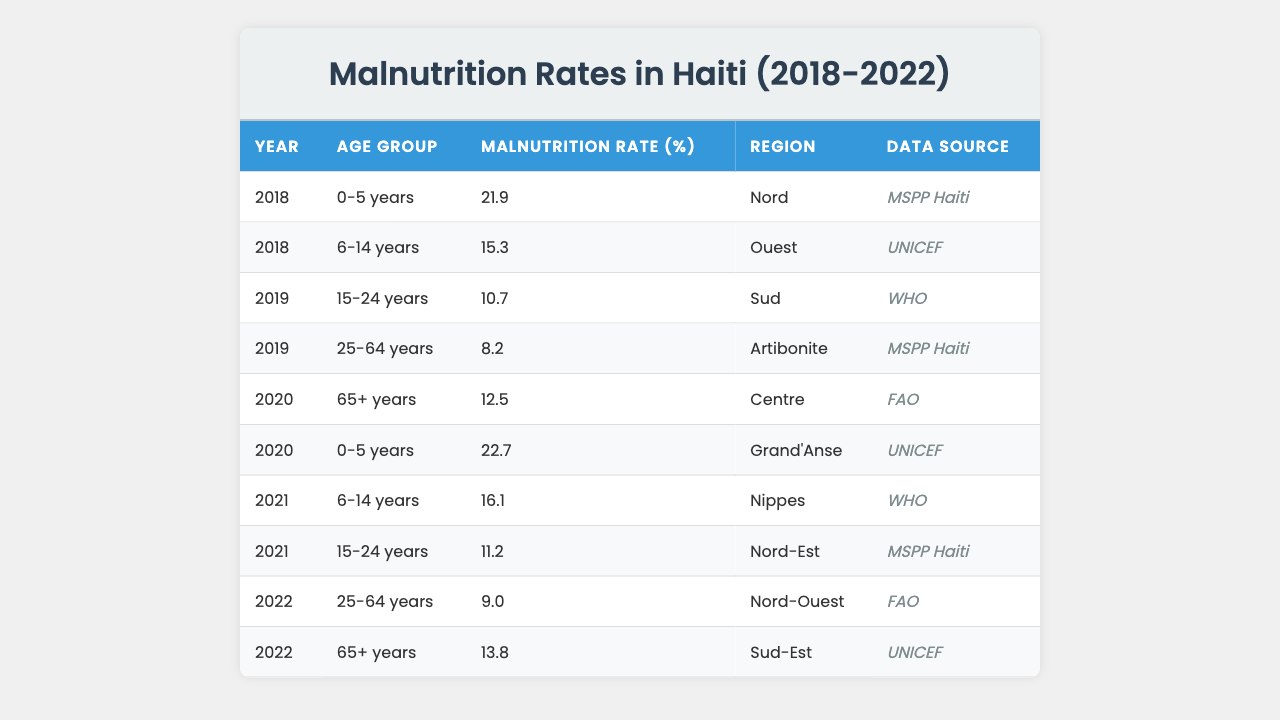What is the malnutrition rate for children aged 0-5 years in 2018? The table indicates that in 2018, the malnutrition rate for the age group 0-5 years is 21.9%.
Answer: 21.9% Which age group had the lowest malnutrition rate in 2019? In 2019, the malnutrition rates were 10.7% for 15-24 years and 8.2% for 25-64 years, making 25-64 years the lowest.
Answer: 25-64 years What was the malnutrition rate for the 65+ age group in 2020? According to the table, in 2020 the malnutrition rate for the 65+ age group is 12.5%.
Answer: 12.5% In how many years did the malnutrition rate for the 0-5 years age group increase from the previous year? The malnutrition rate for the 0-5 years age group increased from 21.9% in 2018 to 22.7% in 2020, indicating an increase for one year.
Answer: One year What is the average malnutrition rate across all age groups for the year 2022? The rates for 2022 are 9.0% for 25-64 years and 13.8% for 65+ years. Their average is (9.0 + 13.8) / 2 = 11.4%.
Answer: 11.4% Is the malnutrition rate for the 6-14 years age group higher in 2021 than in 2018? In 2018, the rate was 15.3% and in 2021 it was 16.1%, confirming that the rate in 2021 is indeed higher.
Answer: Yes How much did the malnutrition rate change for the 15-24 age group from 2019 to 2021? The rate in 2019 was 10.7% and in 2021 it was 11.2%. The change is 11.2% - 10.7% = 0.5%, indicating a small increase.
Answer: Increased by 0.5% Which region had the highest malnutrition rate for the 0-5 age group in 2020? The table shows that in 2020, the region Grand'Anse reported the highest malnutrition rate of 22.7% for this age group.
Answer: Grand'Anse What trend do you observe in malnutrition rates among the 25-64 age group from 2019 to 2022? The rates decreased from 8.2% in 2019 to 9.0% in 2022, indicating a slight upward trend. However, the value returned to lower than previous years, resulting in an overall downward trend.
Answer: Overall downward trend In which year did the malnutrition rate for the 6-14 age group peak? The peak for the 6-14 age group is 16.1% in 2021, compared to 15.3% in 2018 and 2021 observed higher rates.
Answer: 2021 What was the difference in malnutrition rates between the 15-24 and 25-64 age groups in 2022? The malnutrition rate for 15-24 years in 2021 was 11.2% while 9.0% for 25-64 years that year, hence the difference is 11.2% - 9.0% = 2.2%.
Answer: 2.2% 